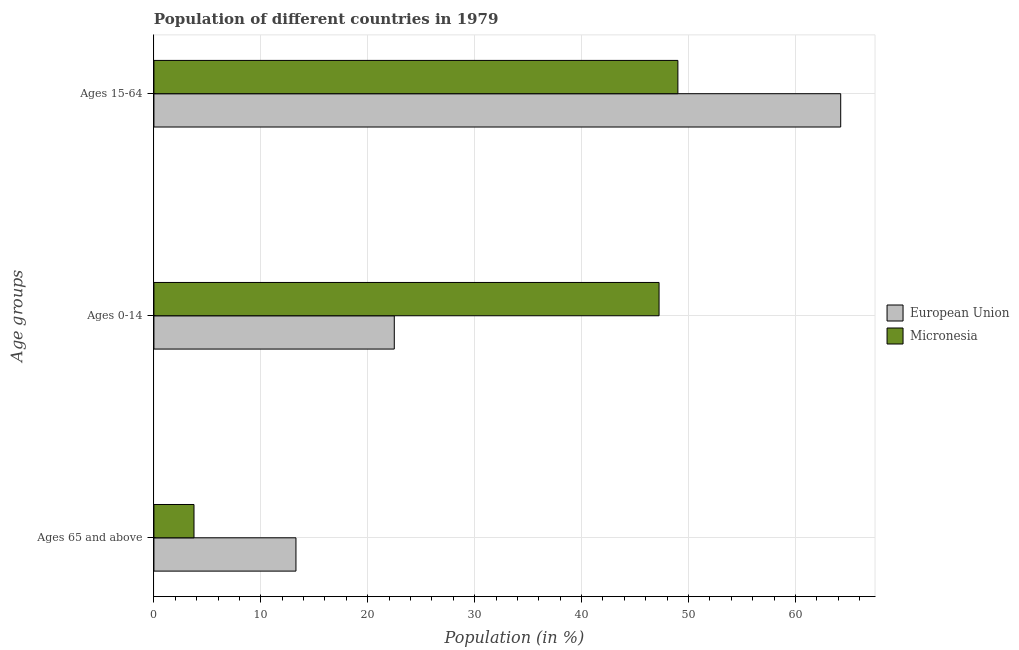How many different coloured bars are there?
Your response must be concise. 2. Are the number of bars per tick equal to the number of legend labels?
Ensure brevity in your answer.  Yes. Are the number of bars on each tick of the Y-axis equal?
Ensure brevity in your answer.  Yes. What is the label of the 3rd group of bars from the top?
Make the answer very short. Ages 65 and above. What is the percentage of population within the age-group 15-64 in European Union?
Offer a terse response. 64.23. Across all countries, what is the maximum percentage of population within the age-group of 65 and above?
Give a very brief answer. 13.28. Across all countries, what is the minimum percentage of population within the age-group 0-14?
Provide a short and direct response. 22.48. In which country was the percentage of population within the age-group 0-14 maximum?
Make the answer very short. Micronesia. In which country was the percentage of population within the age-group 0-14 minimum?
Provide a succinct answer. European Union. What is the total percentage of population within the age-group 15-64 in the graph?
Your answer should be very brief. 113.24. What is the difference between the percentage of population within the age-group 15-64 in European Union and that in Micronesia?
Ensure brevity in your answer.  15.23. What is the difference between the percentage of population within the age-group 0-14 in European Union and the percentage of population within the age-group 15-64 in Micronesia?
Your answer should be very brief. -26.52. What is the average percentage of population within the age-group 0-14 per country?
Your response must be concise. 34.86. What is the difference between the percentage of population within the age-group 15-64 and percentage of population within the age-group 0-14 in Micronesia?
Offer a very short reply. 1.76. What is the ratio of the percentage of population within the age-group 15-64 in European Union to that in Micronesia?
Ensure brevity in your answer.  1.31. Is the difference between the percentage of population within the age-group 0-14 in Micronesia and European Union greater than the difference between the percentage of population within the age-group 15-64 in Micronesia and European Union?
Keep it short and to the point. Yes. What is the difference between the highest and the second highest percentage of population within the age-group of 65 and above?
Offer a terse response. 9.54. What is the difference between the highest and the lowest percentage of population within the age-group 0-14?
Your response must be concise. 24.76. In how many countries, is the percentage of population within the age-group 0-14 greater than the average percentage of population within the age-group 0-14 taken over all countries?
Offer a very short reply. 1. What does the 1st bar from the top in Ages 0-14 represents?
Your response must be concise. Micronesia. What does the 2nd bar from the bottom in Ages 65 and above represents?
Provide a succinct answer. Micronesia. Is it the case that in every country, the sum of the percentage of population within the age-group of 65 and above and percentage of population within the age-group 0-14 is greater than the percentage of population within the age-group 15-64?
Offer a terse response. No. How many countries are there in the graph?
Your answer should be compact. 2. Where does the legend appear in the graph?
Your answer should be compact. Center right. How are the legend labels stacked?
Ensure brevity in your answer.  Vertical. What is the title of the graph?
Ensure brevity in your answer.  Population of different countries in 1979. What is the label or title of the X-axis?
Make the answer very short. Population (in %). What is the label or title of the Y-axis?
Ensure brevity in your answer.  Age groups. What is the Population (in %) in European Union in Ages 65 and above?
Keep it short and to the point. 13.28. What is the Population (in %) in Micronesia in Ages 65 and above?
Provide a short and direct response. 3.75. What is the Population (in %) in European Union in Ages 0-14?
Offer a very short reply. 22.48. What is the Population (in %) of Micronesia in Ages 0-14?
Give a very brief answer. 47.25. What is the Population (in %) in European Union in Ages 15-64?
Your response must be concise. 64.23. What is the Population (in %) in Micronesia in Ages 15-64?
Offer a very short reply. 49.01. Across all Age groups, what is the maximum Population (in %) of European Union?
Your response must be concise. 64.23. Across all Age groups, what is the maximum Population (in %) of Micronesia?
Make the answer very short. 49.01. Across all Age groups, what is the minimum Population (in %) in European Union?
Make the answer very short. 13.28. Across all Age groups, what is the minimum Population (in %) in Micronesia?
Provide a succinct answer. 3.75. What is the difference between the Population (in %) of European Union in Ages 65 and above and that in Ages 0-14?
Offer a very short reply. -9.2. What is the difference between the Population (in %) of Micronesia in Ages 65 and above and that in Ages 0-14?
Ensure brevity in your answer.  -43.5. What is the difference between the Population (in %) of European Union in Ages 65 and above and that in Ages 15-64?
Provide a short and direct response. -50.95. What is the difference between the Population (in %) in Micronesia in Ages 65 and above and that in Ages 15-64?
Keep it short and to the point. -45.26. What is the difference between the Population (in %) of European Union in Ages 0-14 and that in Ages 15-64?
Your answer should be compact. -41.75. What is the difference between the Population (in %) of Micronesia in Ages 0-14 and that in Ages 15-64?
Offer a terse response. -1.76. What is the difference between the Population (in %) of European Union in Ages 65 and above and the Population (in %) of Micronesia in Ages 0-14?
Make the answer very short. -33.96. What is the difference between the Population (in %) in European Union in Ages 65 and above and the Population (in %) in Micronesia in Ages 15-64?
Your response must be concise. -35.72. What is the difference between the Population (in %) of European Union in Ages 0-14 and the Population (in %) of Micronesia in Ages 15-64?
Your response must be concise. -26.52. What is the average Population (in %) of European Union per Age groups?
Offer a terse response. 33.33. What is the average Population (in %) in Micronesia per Age groups?
Provide a succinct answer. 33.33. What is the difference between the Population (in %) of European Union and Population (in %) of Micronesia in Ages 65 and above?
Your answer should be compact. 9.54. What is the difference between the Population (in %) in European Union and Population (in %) in Micronesia in Ages 0-14?
Your answer should be very brief. -24.76. What is the difference between the Population (in %) in European Union and Population (in %) in Micronesia in Ages 15-64?
Offer a very short reply. 15.23. What is the ratio of the Population (in %) in European Union in Ages 65 and above to that in Ages 0-14?
Give a very brief answer. 0.59. What is the ratio of the Population (in %) of Micronesia in Ages 65 and above to that in Ages 0-14?
Your answer should be very brief. 0.08. What is the ratio of the Population (in %) of European Union in Ages 65 and above to that in Ages 15-64?
Ensure brevity in your answer.  0.21. What is the ratio of the Population (in %) in Micronesia in Ages 65 and above to that in Ages 15-64?
Keep it short and to the point. 0.08. What is the ratio of the Population (in %) in Micronesia in Ages 0-14 to that in Ages 15-64?
Your answer should be very brief. 0.96. What is the difference between the highest and the second highest Population (in %) in European Union?
Offer a terse response. 41.75. What is the difference between the highest and the second highest Population (in %) in Micronesia?
Offer a very short reply. 1.76. What is the difference between the highest and the lowest Population (in %) of European Union?
Make the answer very short. 50.95. What is the difference between the highest and the lowest Population (in %) of Micronesia?
Make the answer very short. 45.26. 